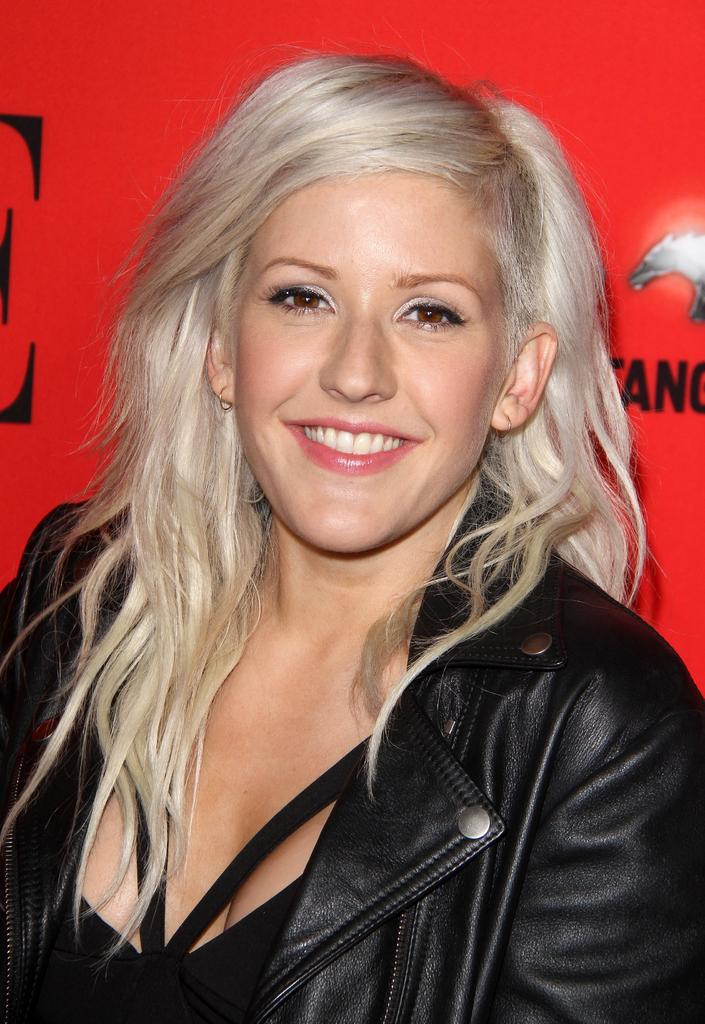Who is present in the image? There is a woman in the image. What is the woman doing in the image? The woman is smiling in the image. What color is the background of the image? The background of the image is red. What type of brass instrument is the woman playing in the image? There is no brass instrument present in the image; the woman is simply smiling. 